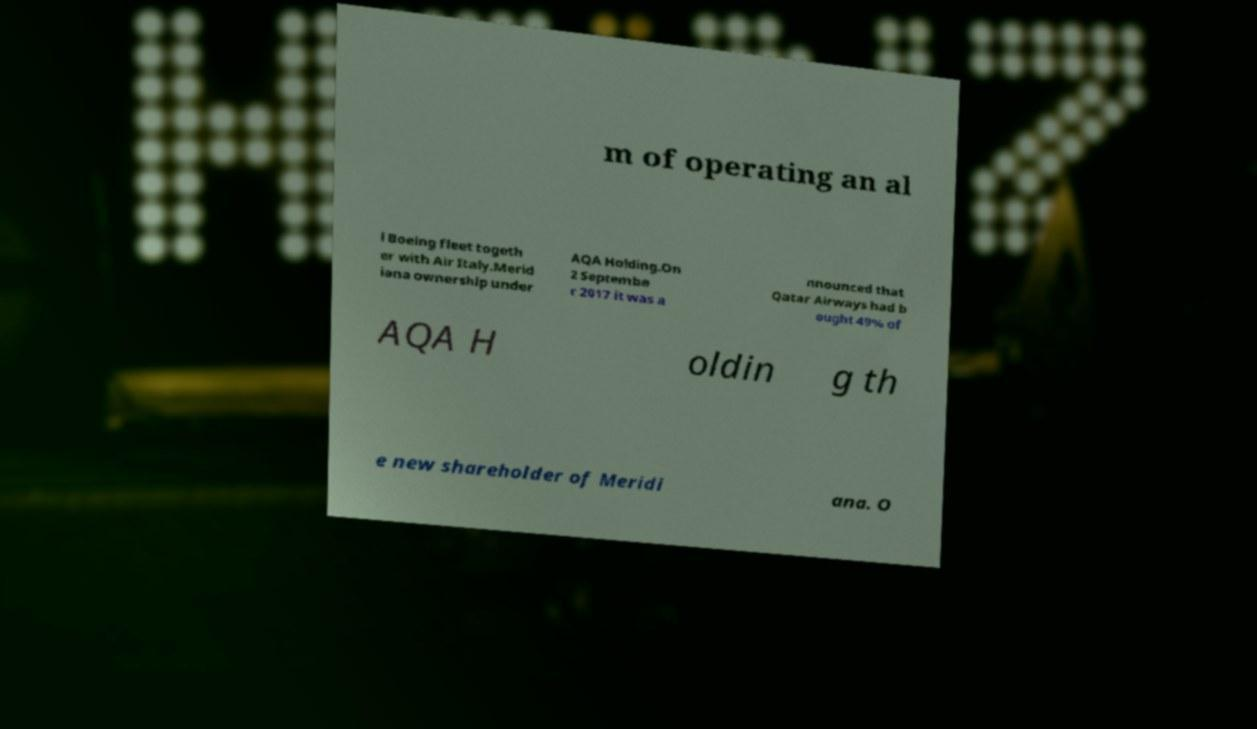Can you read and provide the text displayed in the image?This photo seems to have some interesting text. Can you extract and type it out for me? m of operating an al l Boeing fleet togeth er with Air Italy.Merid iana ownership under AQA Holding.On 2 Septembe r 2017 it was a nnounced that Qatar Airways had b ought 49% of AQA H oldin g th e new shareholder of Meridi ana. O 